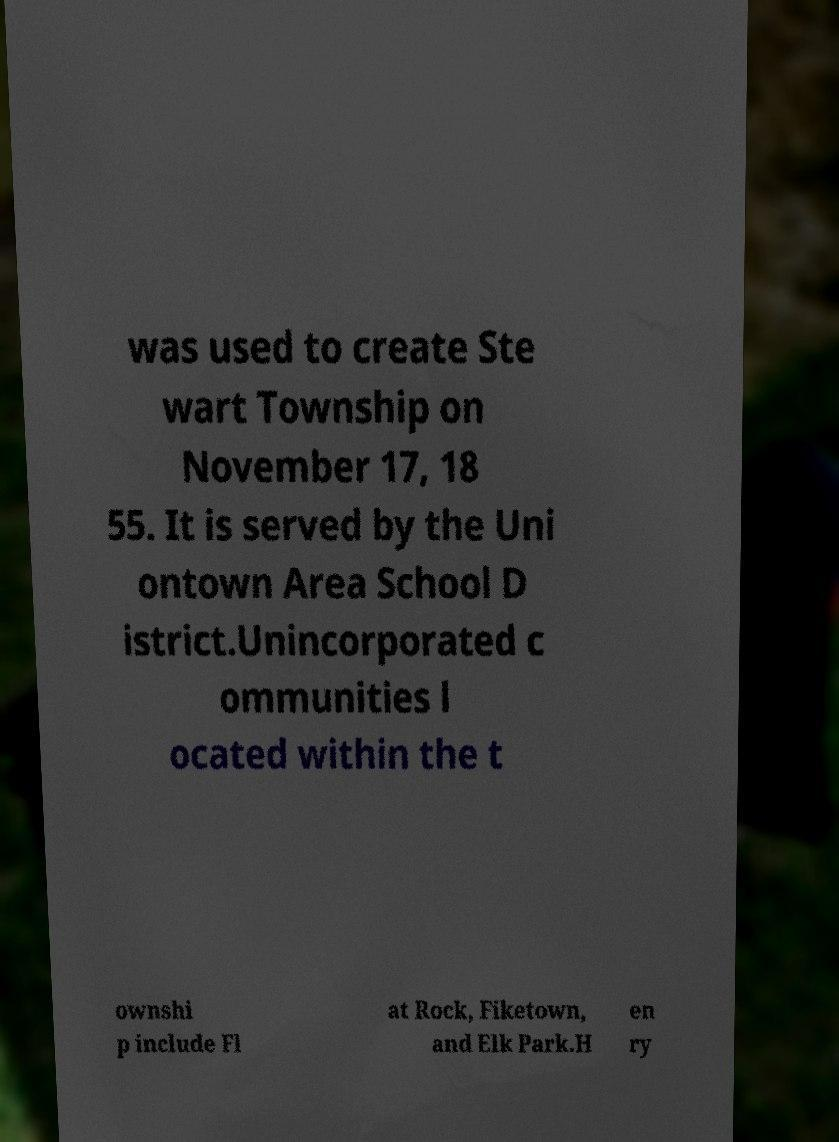What messages or text are displayed in this image? I need them in a readable, typed format. was used to create Ste wart Township on November 17, 18 55. It is served by the Uni ontown Area School D istrict.Unincorporated c ommunities l ocated within the t ownshi p include Fl at Rock, Fiketown, and Elk Park.H en ry 